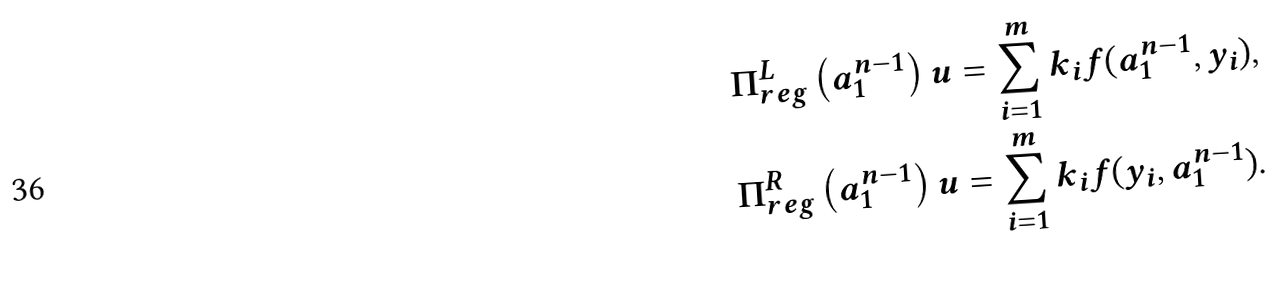Convert formula to latex. <formula><loc_0><loc_0><loc_500><loc_500>\Pi _ { r e g } ^ { L } \left ( a _ { 1 } ^ { n - 1 } \right ) u & = \sum _ { i = 1 } ^ { m } k _ { i } f ( a _ { 1 } ^ { n - 1 } , y _ { i } ) , \\ \Pi _ { r e g } ^ { R } \left ( a _ { 1 } ^ { n - 1 } \right ) u & = \sum _ { i = 1 } ^ { m } k _ { i } f ( y _ { i } , a _ { 1 } ^ { n - 1 } ) .</formula> 